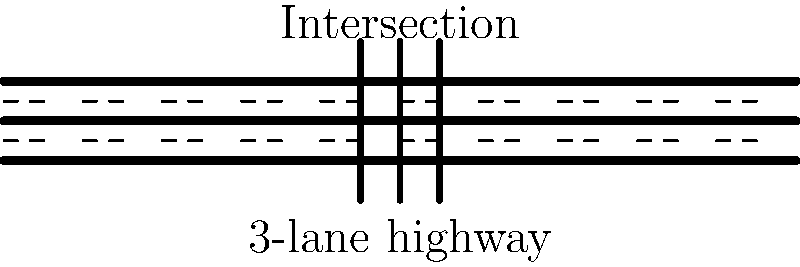As the CEO of the dominant HR platform, you're considering expanding your business into traffic management software. To assess the market potential, you need to understand basic traffic flow concepts. Given a 3-lane highway with an intersection as shown in the diagram, estimate the maximum traffic flow capacity in vehicles per hour (vph) if:

1. The average vehicle speed is 60 mph
2. The average vehicle length is 15 feet
3. The safe following distance is 2 seconds
4. The intersection has a 60-second signal cycle with 30 seconds of green time for the highway

Assume ideal conditions and that the intersection is the limiting factor for capacity. To estimate the maximum traffic flow capacity, we'll follow these steps:

1. Calculate the capacity of a single lane without the intersection:
   - At 60 mph, a vehicle travels 88 feet/second
   - Safe following distance = 2 seconds * 88 ft/s = 176 feet
   - Space per vehicle = 176 feet + 15 feet (vehicle length) = 191 feet
   - Capacity = $\frac{3600 \text{ seconds/hour} * 60 \text{ mph}}{191 \text{ feet/vehicle}} = 1131 \text{ vph/lane}$

2. Adjust for the intersection:
   - Green time ratio = 30 seconds / 60 seconds = 0.5
   - Adjusted capacity per lane = 1131 vph/lane * 0.5 = 565.5 vph/lane

3. Calculate total capacity for 3 lanes:
   - Total capacity = 565.5 vph/lane * 3 lanes = 1696.5 vph

4. Round to a reasonable precision:
   - Estimated maximum capacity ≈ 1700 vph

This estimate assumes ideal conditions and that all vehicles can clear the intersection during the green phase. In reality, factors such as driver behavior, weather, and turning movements would affect the actual capacity.
Answer: 1700 vph 